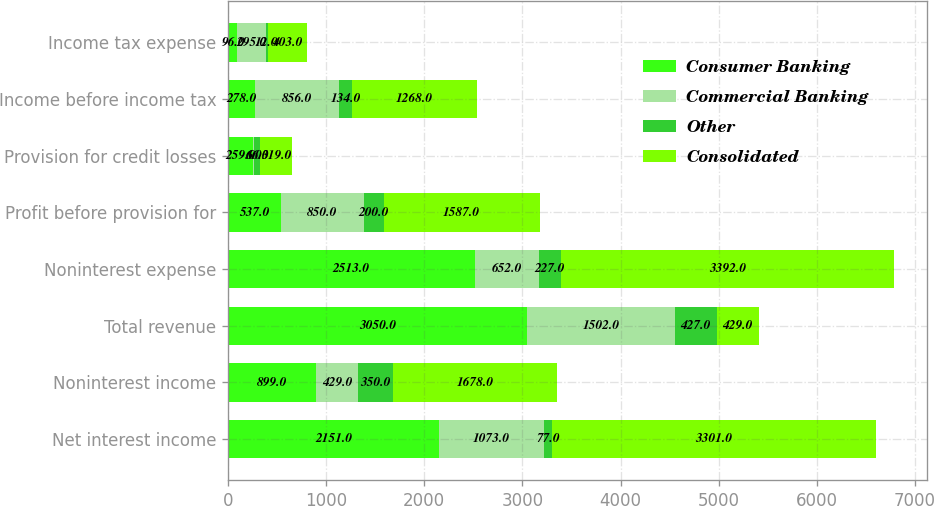<chart> <loc_0><loc_0><loc_500><loc_500><stacked_bar_chart><ecel><fcel>Net interest income<fcel>Noninterest income<fcel>Total revenue<fcel>Noninterest expense<fcel>Profit before provision for<fcel>Provision for credit losses<fcel>Income before income tax<fcel>Income tax expense<nl><fcel>Consumer Banking<fcel>2151<fcel>899<fcel>3050<fcel>2513<fcel>537<fcel>259<fcel>278<fcel>96<nl><fcel>Commercial Banking<fcel>1073<fcel>429<fcel>1502<fcel>652<fcel>850<fcel>6<fcel>856<fcel>295<nl><fcel>Other<fcel>77<fcel>350<fcel>427<fcel>227<fcel>200<fcel>66<fcel>134<fcel>12<nl><fcel>Consolidated<fcel>3301<fcel>1678<fcel>429<fcel>3392<fcel>1587<fcel>319<fcel>1268<fcel>403<nl></chart> 